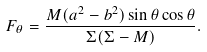Convert formula to latex. <formula><loc_0><loc_0><loc_500><loc_500>F _ { \theta } = \frac { M ( a ^ { 2 } - b ^ { 2 } ) \sin \theta \cos \theta } { \Sigma ( \Sigma - M ) } .</formula> 